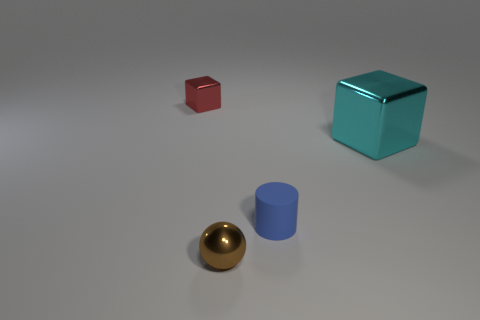Add 4 small matte objects. How many objects exist? 8 Subtract all balls. How many objects are left? 3 Subtract all brown metallic balls. Subtract all blue matte cylinders. How many objects are left? 2 Add 3 large cyan objects. How many large cyan objects are left? 4 Add 3 big purple metal objects. How many big purple metal objects exist? 3 Subtract 0 green spheres. How many objects are left? 4 